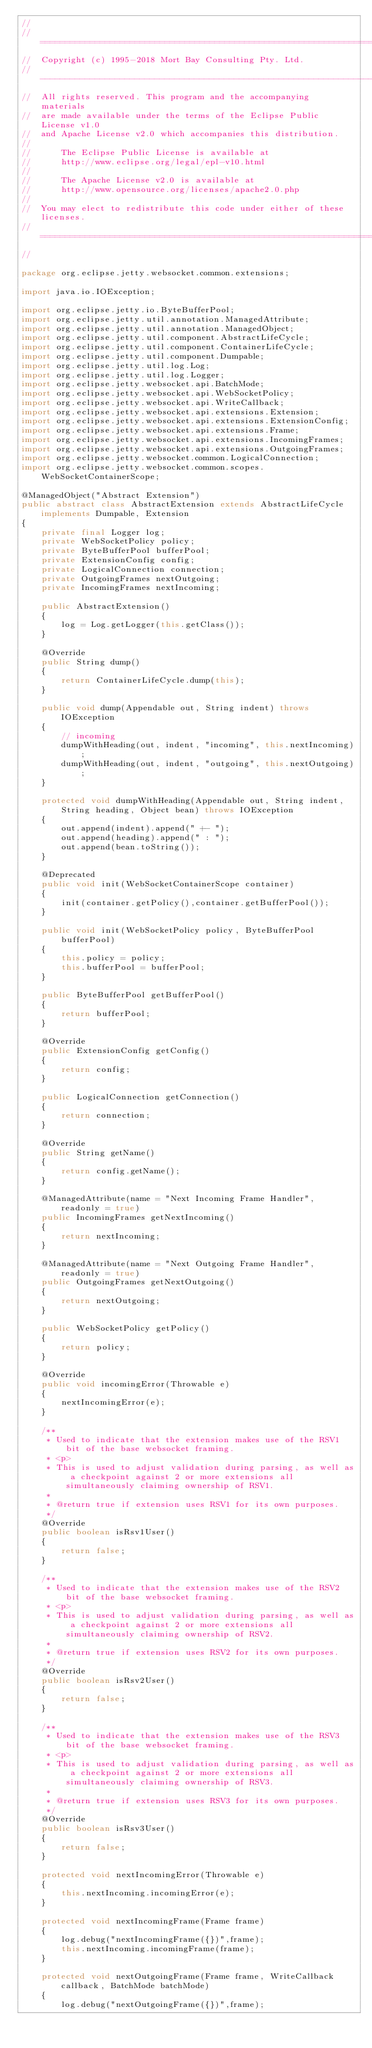<code> <loc_0><loc_0><loc_500><loc_500><_Java_>//
//  ========================================================================
//  Copyright (c) 1995-2018 Mort Bay Consulting Pty. Ltd.
//  ------------------------------------------------------------------------
//  All rights reserved. This program and the accompanying materials
//  are made available under the terms of the Eclipse Public License v1.0
//  and Apache License v2.0 which accompanies this distribution.
//
//      The Eclipse Public License is available at
//      http://www.eclipse.org/legal/epl-v10.html
//
//      The Apache License v2.0 is available at
//      http://www.opensource.org/licenses/apache2.0.php
//
//  You may elect to redistribute this code under either of these licenses.
//  ========================================================================
//

package org.eclipse.jetty.websocket.common.extensions;

import java.io.IOException;

import org.eclipse.jetty.io.ByteBufferPool;
import org.eclipse.jetty.util.annotation.ManagedAttribute;
import org.eclipse.jetty.util.annotation.ManagedObject;
import org.eclipse.jetty.util.component.AbstractLifeCycle;
import org.eclipse.jetty.util.component.ContainerLifeCycle;
import org.eclipse.jetty.util.component.Dumpable;
import org.eclipse.jetty.util.log.Log;
import org.eclipse.jetty.util.log.Logger;
import org.eclipse.jetty.websocket.api.BatchMode;
import org.eclipse.jetty.websocket.api.WebSocketPolicy;
import org.eclipse.jetty.websocket.api.WriteCallback;
import org.eclipse.jetty.websocket.api.extensions.Extension;
import org.eclipse.jetty.websocket.api.extensions.ExtensionConfig;
import org.eclipse.jetty.websocket.api.extensions.Frame;
import org.eclipse.jetty.websocket.api.extensions.IncomingFrames;
import org.eclipse.jetty.websocket.api.extensions.OutgoingFrames;
import org.eclipse.jetty.websocket.common.LogicalConnection;
import org.eclipse.jetty.websocket.common.scopes.WebSocketContainerScope;

@ManagedObject("Abstract Extension")
public abstract class AbstractExtension extends AbstractLifeCycle implements Dumpable, Extension
{
    private final Logger log;
    private WebSocketPolicy policy;
    private ByteBufferPool bufferPool;
    private ExtensionConfig config;
    private LogicalConnection connection;
    private OutgoingFrames nextOutgoing;
    private IncomingFrames nextIncoming;

    public AbstractExtension()
    {
        log = Log.getLogger(this.getClass());
    }
    
    @Override
    public String dump()
    {
        return ContainerLifeCycle.dump(this);
    }

    public void dump(Appendable out, String indent) throws IOException
    {
        // incoming
        dumpWithHeading(out, indent, "incoming", this.nextIncoming);
        dumpWithHeading(out, indent, "outgoing", this.nextOutgoing);
    }

    protected void dumpWithHeading(Appendable out, String indent, String heading, Object bean) throws IOException
    {
        out.append(indent).append(" +- ");
        out.append(heading).append(" : ");
        out.append(bean.toString());
    }
    
    @Deprecated
    public void init(WebSocketContainerScope container)
    {
        init(container.getPolicy(),container.getBufferPool());
    }
    
    public void init(WebSocketPolicy policy, ByteBufferPool bufferPool)
    {
        this.policy = policy;
        this.bufferPool = bufferPool;
    }

    public ByteBufferPool getBufferPool()
    {
        return bufferPool;
    }

    @Override
    public ExtensionConfig getConfig()
    {
        return config;
    }

    public LogicalConnection getConnection()
    {
        return connection;
    }

    @Override
    public String getName()
    {
        return config.getName();
    }

    @ManagedAttribute(name = "Next Incoming Frame Handler", readonly = true)
    public IncomingFrames getNextIncoming()
    {
        return nextIncoming;
    }

    @ManagedAttribute(name = "Next Outgoing Frame Handler", readonly = true)
    public OutgoingFrames getNextOutgoing()
    {
        return nextOutgoing;
    }

    public WebSocketPolicy getPolicy()
    {
        return policy;
    }

    @Override
    public void incomingError(Throwable e)
    {
        nextIncomingError(e);
    }

    /**
     * Used to indicate that the extension makes use of the RSV1 bit of the base websocket framing.
     * <p>
     * This is used to adjust validation during parsing, as well as a checkpoint against 2 or more extensions all simultaneously claiming ownership of RSV1.
     * 
     * @return true if extension uses RSV1 for its own purposes.
     */
    @Override
    public boolean isRsv1User()
    {
        return false;
    }

    /**
     * Used to indicate that the extension makes use of the RSV2 bit of the base websocket framing.
     * <p>
     * This is used to adjust validation during parsing, as well as a checkpoint against 2 or more extensions all simultaneously claiming ownership of RSV2.
     * 
     * @return true if extension uses RSV2 for its own purposes.
     */
    @Override
    public boolean isRsv2User()
    {
        return false;
    }

    /**
     * Used to indicate that the extension makes use of the RSV3 bit of the base websocket framing.
     * <p>
     * This is used to adjust validation during parsing, as well as a checkpoint against 2 or more extensions all simultaneously claiming ownership of RSV3.
     * 
     * @return true if extension uses RSV3 for its own purposes.
     */
    @Override
    public boolean isRsv3User()
    {
        return false;
    }

    protected void nextIncomingError(Throwable e)
    {
        this.nextIncoming.incomingError(e);
    }

    protected void nextIncomingFrame(Frame frame)
    {
        log.debug("nextIncomingFrame({})",frame);
        this.nextIncoming.incomingFrame(frame);
    }

    protected void nextOutgoingFrame(Frame frame, WriteCallback callback, BatchMode batchMode)
    {
        log.debug("nextOutgoingFrame({})",frame);</code> 